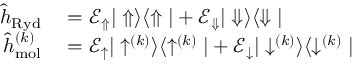Convert formula to latex. <formula><loc_0><loc_0><loc_500><loc_500>\begin{array} { r l } { \hat { h } _ { R y d } } & = \mathcal { E } _ { \Uparrow } | \Uparrow \rangle \langle \Uparrow | + \mathcal { E } _ { \Downarrow } | \Downarrow \rangle \langle \Downarrow | } \\ { \hat { h } _ { m o l } ^ { ( k ) } } & = \mathcal { E } _ { \uparrow } | \uparrow ^ { ( k ) } \rangle \langle \uparrow ^ { ( k ) } | + \mathcal { E } _ { \downarrow } | \downarrow ^ { ( k ) } \rangle \langle \downarrow ^ { ( k ) } | } \end{array}</formula> 